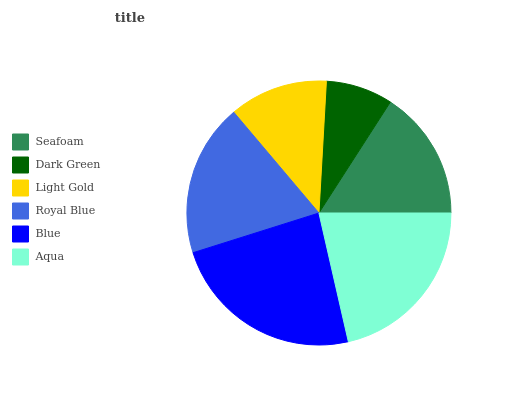Is Dark Green the minimum?
Answer yes or no. Yes. Is Blue the maximum?
Answer yes or no. Yes. Is Light Gold the minimum?
Answer yes or no. No. Is Light Gold the maximum?
Answer yes or no. No. Is Light Gold greater than Dark Green?
Answer yes or no. Yes. Is Dark Green less than Light Gold?
Answer yes or no. Yes. Is Dark Green greater than Light Gold?
Answer yes or no. No. Is Light Gold less than Dark Green?
Answer yes or no. No. Is Royal Blue the high median?
Answer yes or no. Yes. Is Seafoam the low median?
Answer yes or no. Yes. Is Seafoam the high median?
Answer yes or no. No. Is Dark Green the low median?
Answer yes or no. No. 